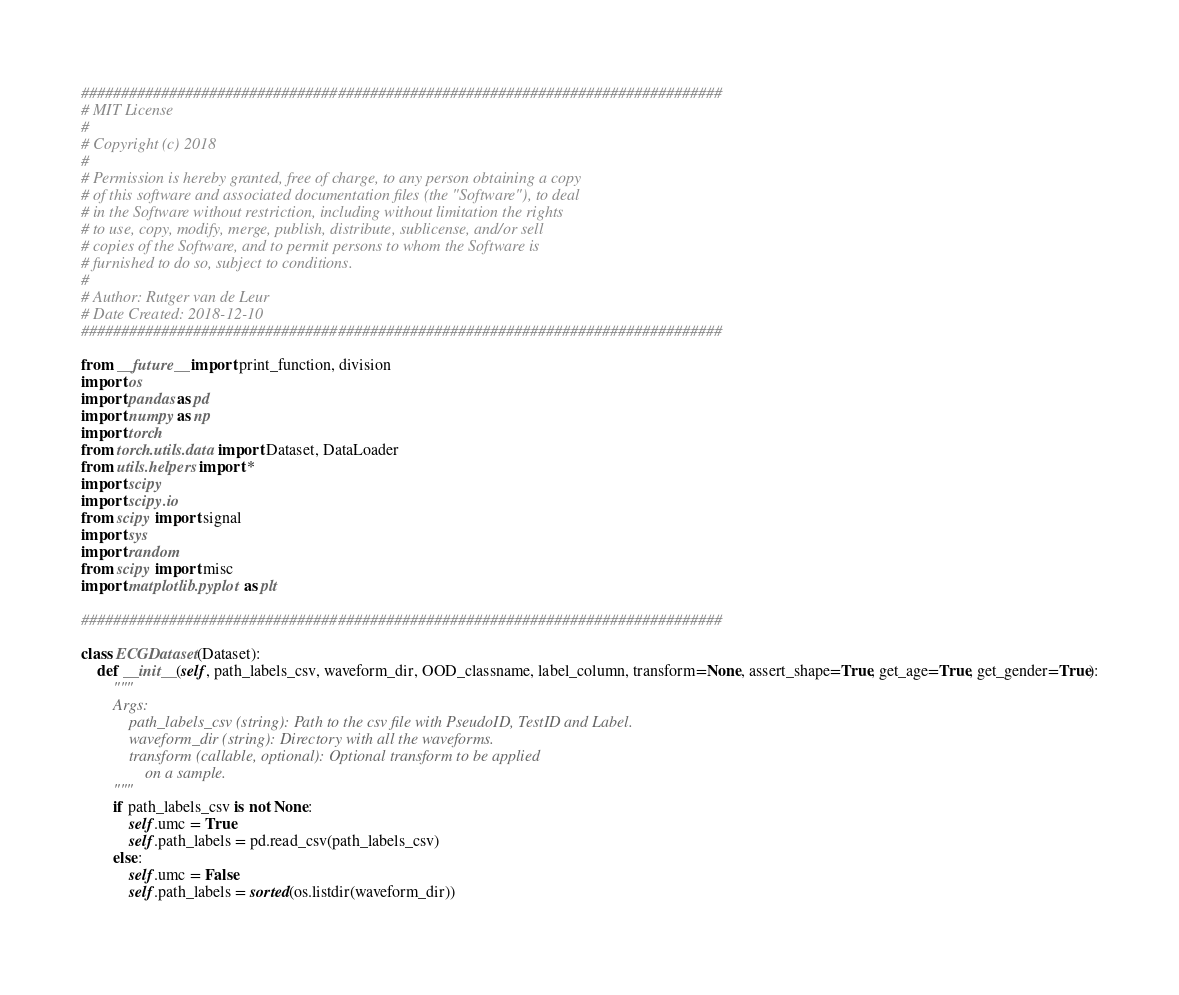Convert code to text. <code><loc_0><loc_0><loc_500><loc_500><_Python_>################################################################################
# MIT License
# 
# Copyright (c) 2018
# 
# Permission is hereby granted, free of charge, to any person obtaining a copy
# of this software and associated documentation files (the "Software"), to deal
# in the Software without restriction, including without limitation the rights
# to use, copy, modify, merge, publish, distribute, sublicense, and/or sell
# copies of the Software, and to permit persons to whom the Software is
# furnished to do so, subject to conditions.
#
# Author: Rutger van de Leur
# Date Created: 2018-12-10
################################################################################

from __future__ import print_function, division
import os
import pandas as pd
import numpy as np
import torch
from torch.utils.data import Dataset, DataLoader
from utils.helpers import *
import scipy
import scipy.io
from scipy import signal
import sys
import random
from scipy import misc
import matplotlib.pyplot as plt

################################################################################

class ECGDataset(Dataset):
    def __init__(self, path_labels_csv, waveform_dir, OOD_classname, label_column, transform=None, assert_shape=True, get_age=True, get_gender=True):
        """
        Args:
            path_labels_csv (string): Path to the csv file with PseudoID, TestID and Label.
            waveform_dir (string): Directory with all the waveforms.
            transform (callable, optional): Optional transform to be applied
                on a sample.
        """
        if path_labels_csv is not None:
            self.umc = True
            self.path_labels = pd.read_csv(path_labels_csv)
        else:
            self.umc = False
            self.path_labels = sorted(os.listdir(waveform_dir))
        </code> 